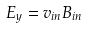Convert formula to latex. <formula><loc_0><loc_0><loc_500><loc_500>E _ { y } = v _ { i n } B _ { i n }</formula> 